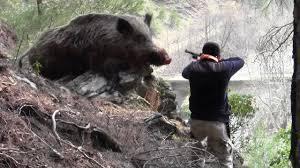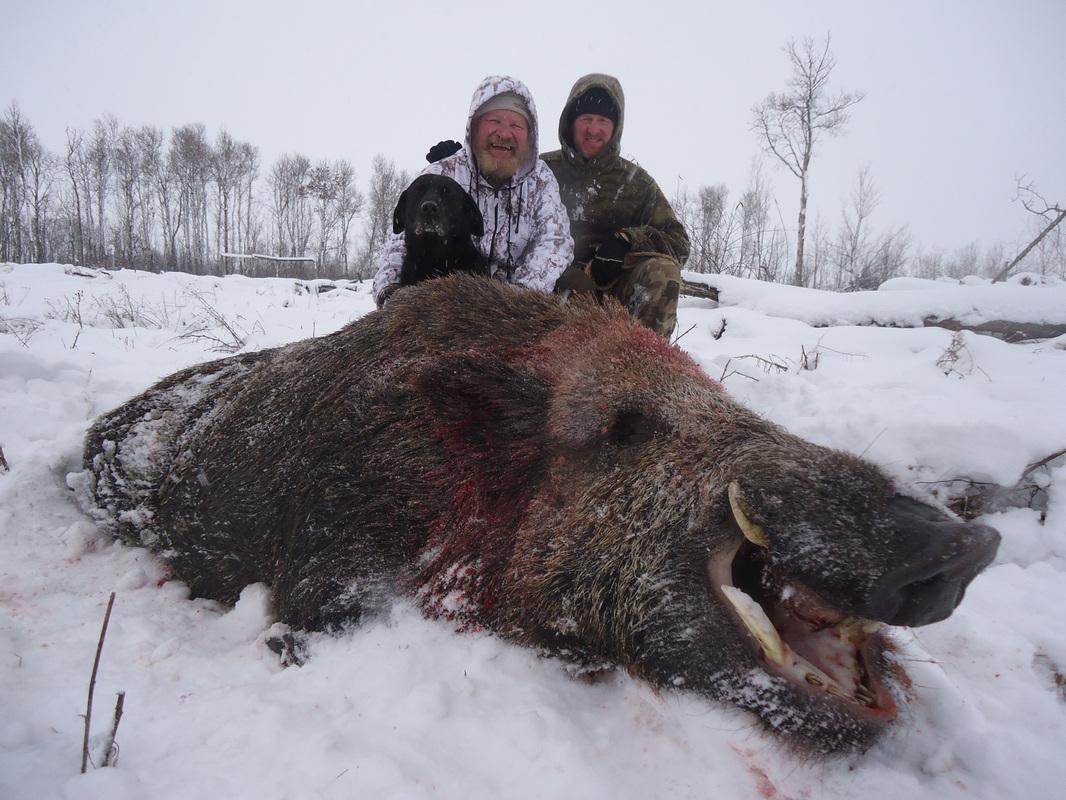The first image is the image on the left, the second image is the image on the right. Considering the images on both sides, is "One of the images has at least one person posing over a dead animal on snowy ground." valid? Answer yes or no. Yes. The first image is the image on the left, the second image is the image on the right. Assess this claim about the two images: "A man is holding a gun horizontally.". Correct or not? Answer yes or no. Yes. 